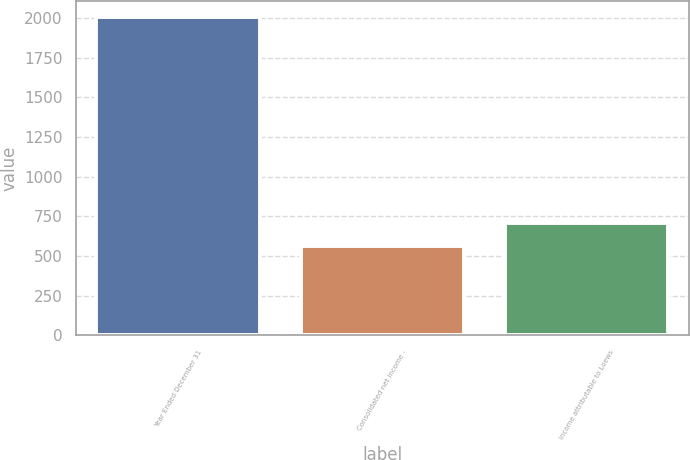Convert chart to OTSL. <chart><loc_0><loc_0><loc_500><loc_500><bar_chart><fcel>Year Ended December 31<fcel>Consolidated net income -<fcel>Income attributable to Loews<nl><fcel>2009<fcel>564<fcel>708.5<nl></chart> 